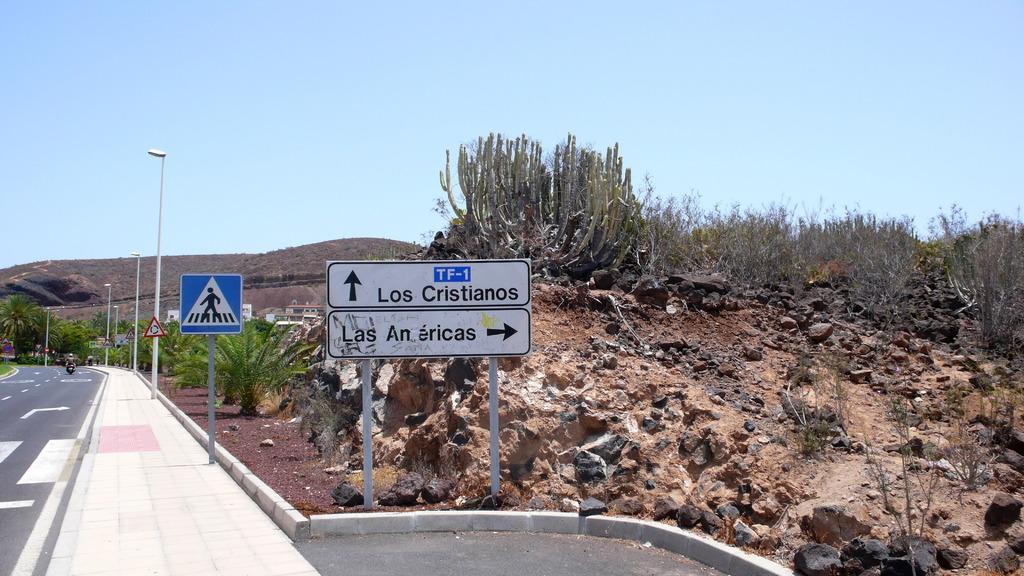In one or two sentences, can you explain what this image depicts? This picture is clicked outside the city. At the bottom of the picture, we see the road and we see a man is riding the bike on the road. Beside him, we see a footpath on which street lights and a pedestrian board are placed. In the middle of the picture, we see a white board with some text written on it. Behind that, we see a rock and plants. There are trees and hills in the background. At the top of the picture, we see the sky. 